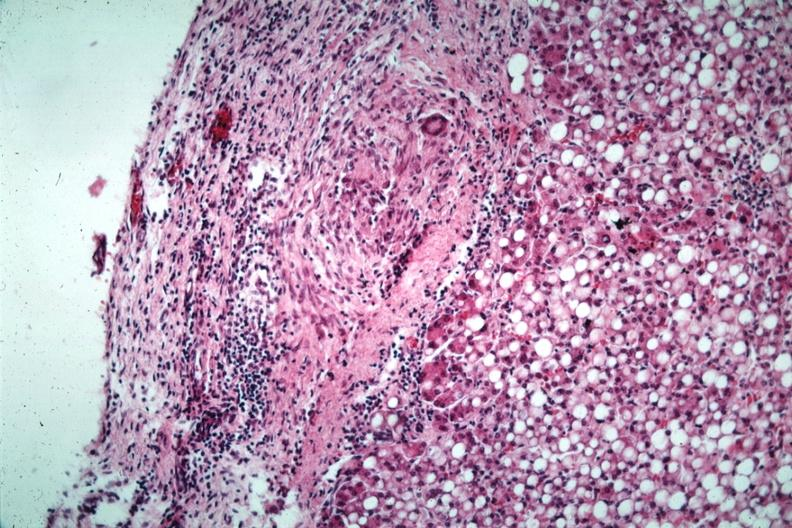what has quite good liver marked?
Answer the question using a single word or phrase. Marked fatty change 